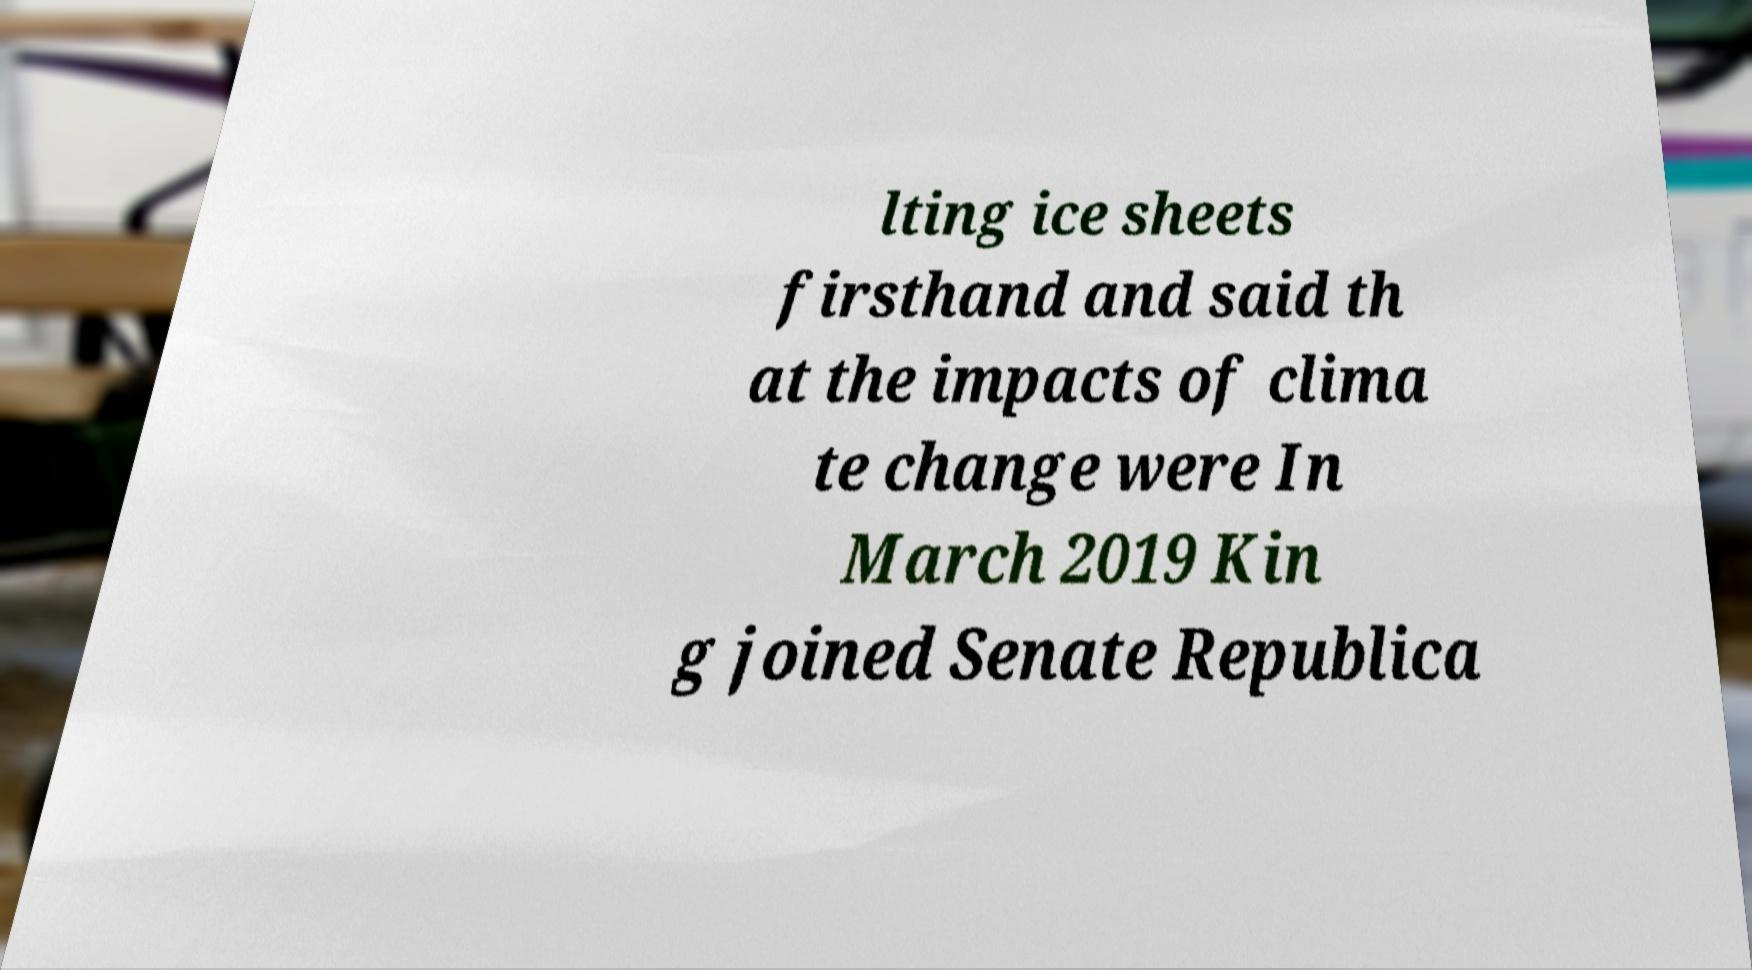Please read and relay the text visible in this image. What does it say? lting ice sheets firsthand and said th at the impacts of clima te change were In March 2019 Kin g joined Senate Republica 